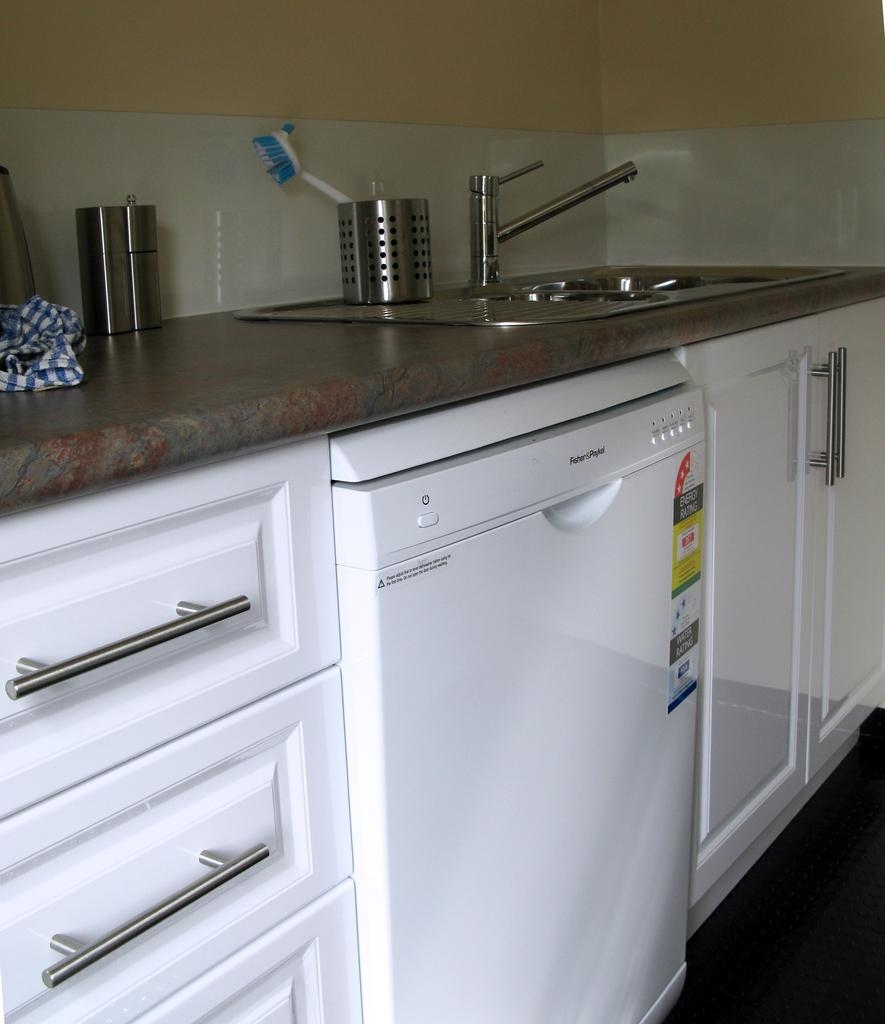What type of furniture is present in the image? There is a table in the image. Are there any storage units visible in the image? Yes, there are cabinets in the image. What is located on the table in the image? There is a tap, bowls, and a cloth on the table. What can be seen on the wall in the image? The wall is visible at the top of the image. Can you tell me how many buckets are placed on the table in the image? There are no buckets present on the table in the image. Is there anyone getting a haircut in the image? There is no haircut being performed in the image. 